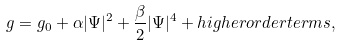Convert formula to latex. <formula><loc_0><loc_0><loc_500><loc_500>g = g _ { 0 } + \alpha | \Psi | ^ { 2 } + \frac { \beta } { 2 } | \Psi | ^ { 4 } + h i g h e r o r d e r t e r m s ,</formula> 